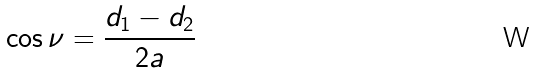<formula> <loc_0><loc_0><loc_500><loc_500>\cos \nu = \frac { d _ { 1 } - d _ { 2 } } { 2 a }</formula> 